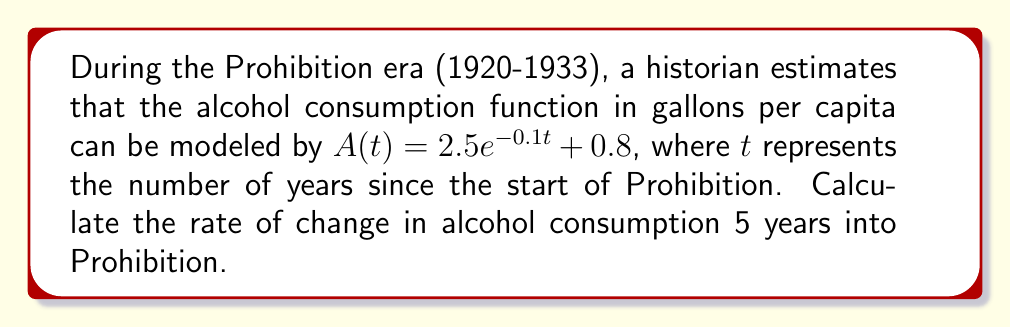Show me your answer to this math problem. To find the rate of change in alcohol consumption, we need to calculate the derivative of the given function and evaluate it at $t=5$. Let's follow these steps:

1) The given function is $A(t) = 2.5e^{-0.1t} + 0.8$

2) To find the derivative, we use the chain rule on the exponential term:

   $$\frac{d}{dt}[2.5e^{-0.1t}] = 2.5 \cdot (-0.1) \cdot e^{-0.1t} = -0.25e^{-0.1t}$$

3) The constant term 0.8 disappears when we take the derivative.

4) Thus, the derivative (rate of change) function is:

   $$A'(t) = -0.25e^{-0.1t}$$

5) To find the rate of change 5 years into Prohibition, we evaluate $A'(5)$:

   $$A'(5) = -0.25e^{-0.1(5)} = -0.25e^{-0.5}$$

6) Using a calculator or approximating:

   $$A'(5) \approx -0.1517$$

The negative value indicates that alcohol consumption was decreasing at this point in time.
Answer: $-0.1517$ gallons per capita per year 